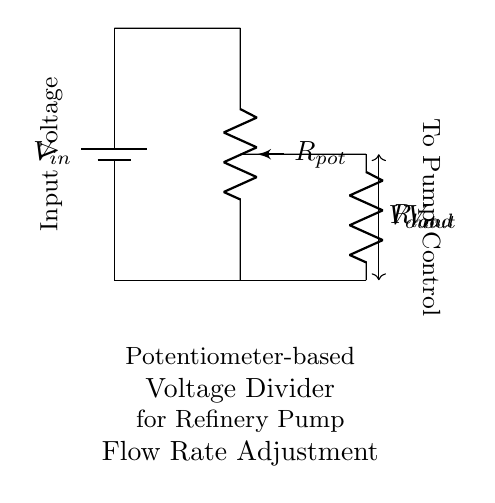What is the type of voltage divider shown? The circuit diagram illustrates a potentiometer-based voltage divider, which makes use of a potentiometer as the adjustable resistance to control voltage output.
Answer: Potentiometer-based What is the load resistor labeled as? In the circuit diagram, the load resistor is denoted as R_load, which is connected in parallel with the potentiometer output and is responsible for drawing current.
Answer: R_load What does the output voltage control? The output voltage, indicated as V_out, is directed to the pump control mechanism, implying it regulates the flow rate of the refinery pumps.
Answer: Flow rate What is the function of the potentiometer in this circuit? The potentiometer serves as a variable resistor that allows for the adjustment of the output voltage by changing the resistance, thus modifying the flow rate of the refinery pumps.
Answer: Adjustable resistance What happens to V_out if R_load increases? An increase in R_load will lead to a decrease in V_out, as higher load resistance results in a lower current through the voltage divider, affecting voltage distribution across the resistances.
Answer: Decreases What is connected to the input voltage source? The input voltage source, marked as V_in, is connected to the top terminal of the potentiometer, enabling the voltage divider to draw from this supply.
Answer: Potentiometer 